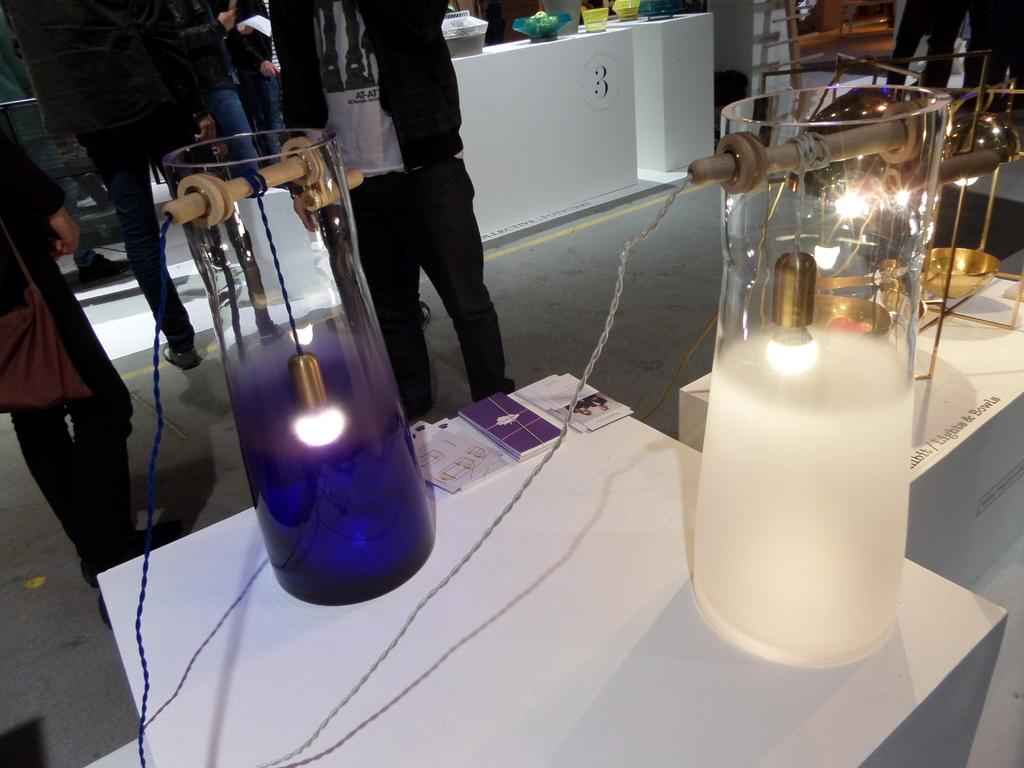What type of objects can be seen in the image? There are lights, jars, wires, tables, books, and other objects in the image. What is the purpose of the wires in the image? The purpose of the wires is not explicitly stated, but they may be used for connecting or powering the lights or other devices. How many tables are visible in the image? There are tables in the image, but the exact number is not specified. What are the persons standing on the floor doing? The actions of the persons standing on the floor are not described in the facts, so it cannot be determined from the image. Can you tell me how many dogs are sitting on the tables in the image? There are no dogs present in the image; it features lights, jars, wires, tables, books, and other objects. What type of twig is being used as a rule by the persons standing on the floor? There is no twig or rule present in the image, and therefore no such activity can be observed. 